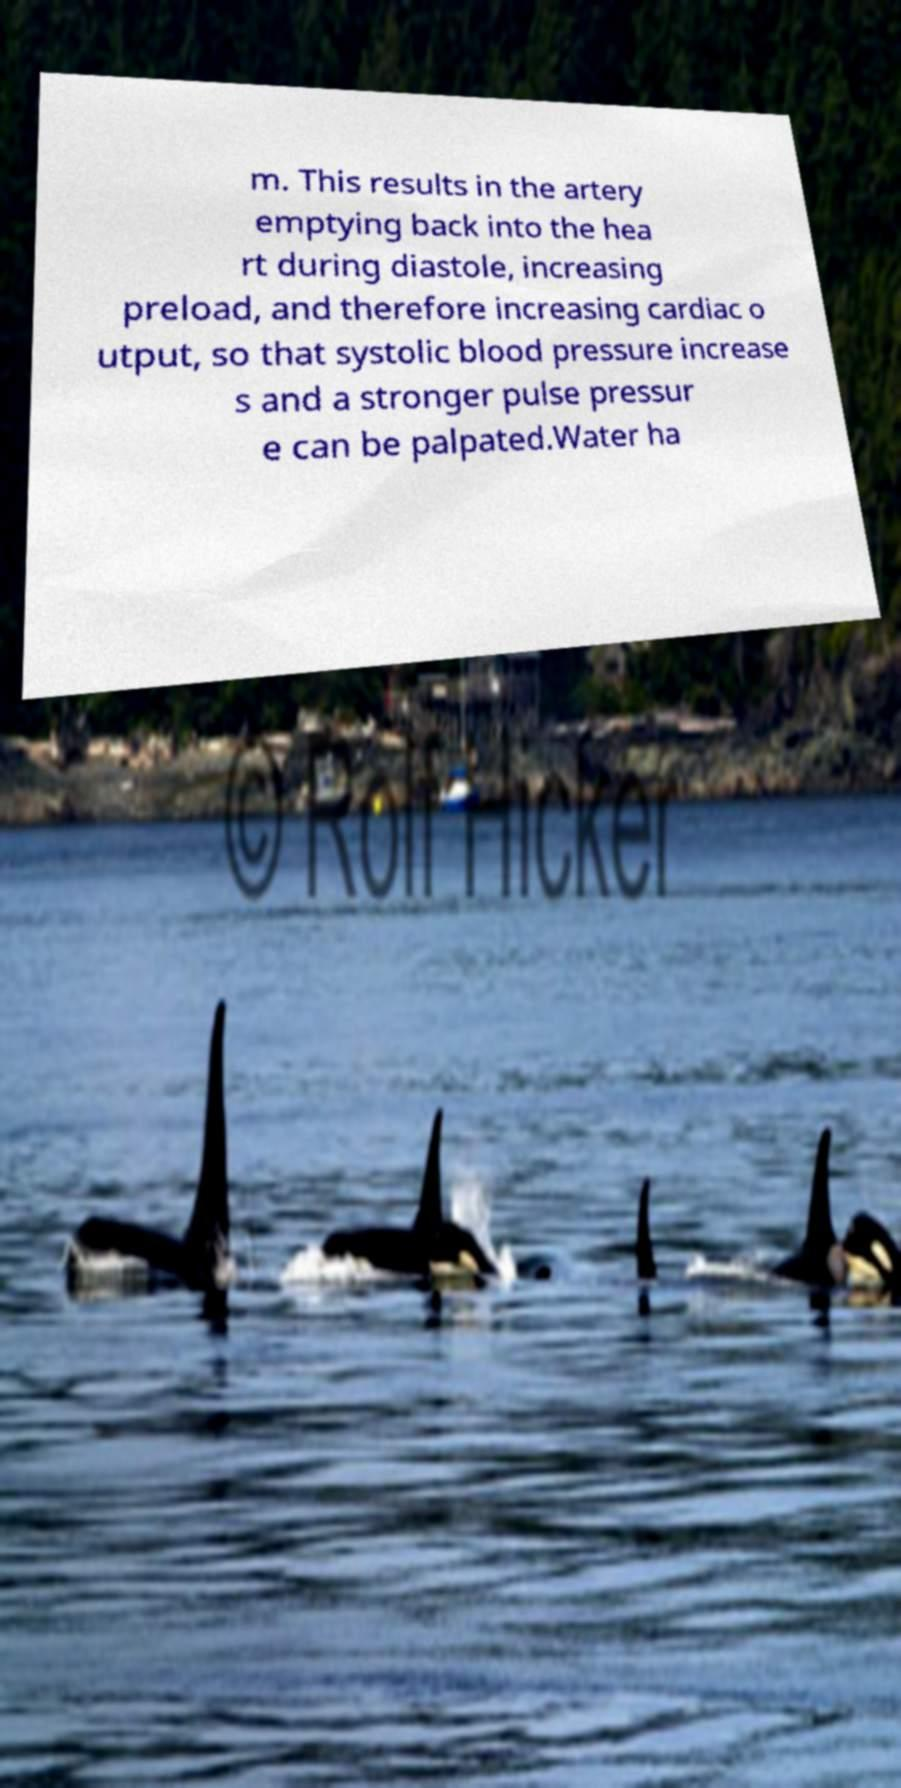Can you accurately transcribe the text from the provided image for me? m. This results in the artery emptying back into the hea rt during diastole, increasing preload, and therefore increasing cardiac o utput, so that systolic blood pressure increase s and a stronger pulse pressur e can be palpated.Water ha 